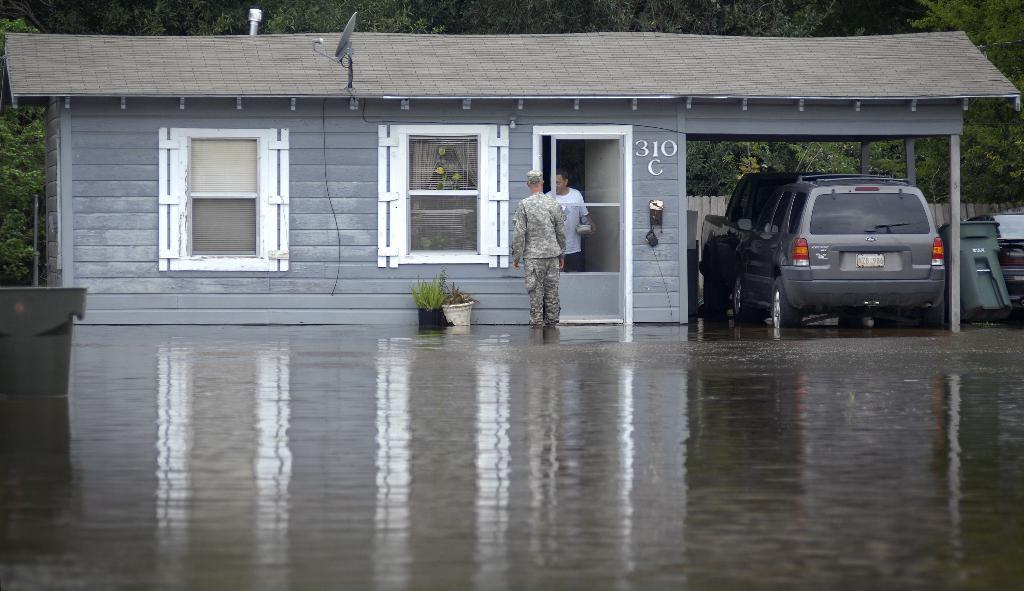Please provide a concise description of this image. In this image we can see a house with white color windows and door. Right side of the image dustbin and car is there. Bottom of the image water is present. Behind the house trees are there. One antenna is attached to the roof of the house. 